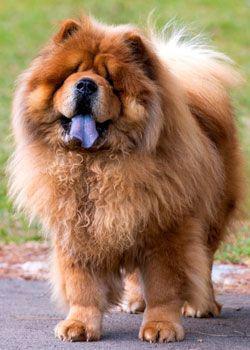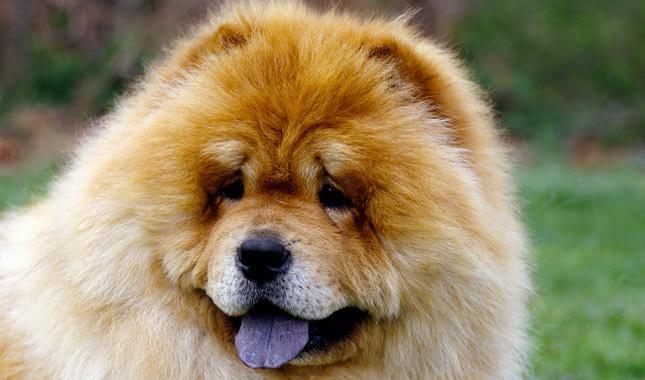The first image is the image on the left, the second image is the image on the right. Examine the images to the left and right. Is the description "Two dogs have their mouths open and tongues sticking out." accurate? Answer yes or no. Yes. The first image is the image on the left, the second image is the image on the right. Assess this claim about the two images: "The dogs in both images are sticking their tongues out.". Correct or not? Answer yes or no. Yes. 